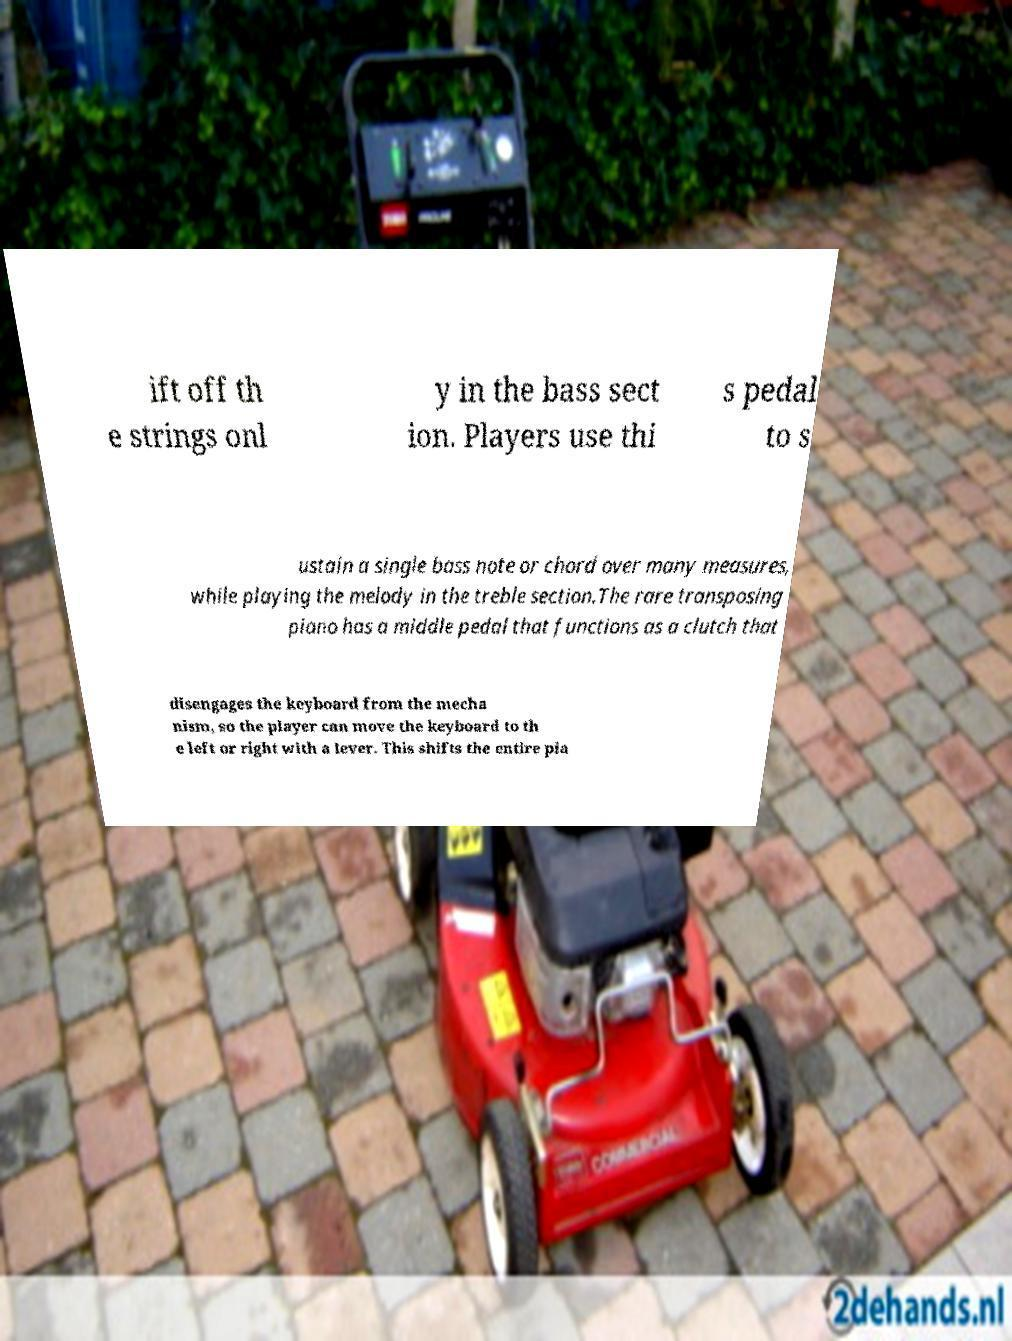Can you read and provide the text displayed in the image?This photo seems to have some interesting text. Can you extract and type it out for me? ift off th e strings onl y in the bass sect ion. Players use thi s pedal to s ustain a single bass note or chord over many measures, while playing the melody in the treble section.The rare transposing piano has a middle pedal that functions as a clutch that disengages the keyboard from the mecha nism, so the player can move the keyboard to th e left or right with a lever. This shifts the entire pia 